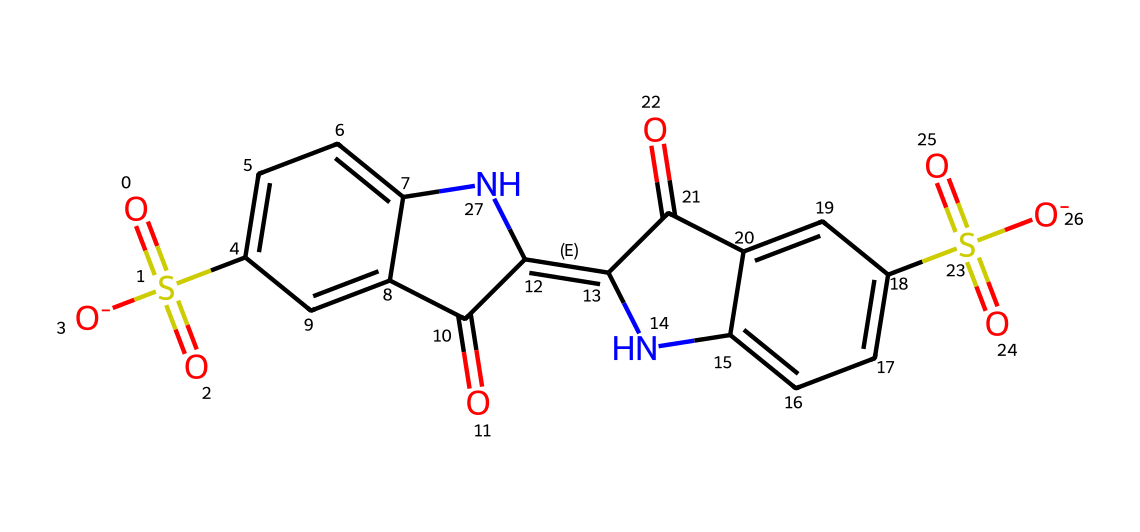How many rings are present in the molecular structure of indigo carmine? The structure shows two fused ring systems, indicating there are two rings present in the molecule.
Answer: two What is the oxidation state of the sulfur atom in indigo carmine? The sulfur atoms are associated with sulfonic acid groups, thus they are in the +6 oxidation state.
Answer: +6 How many nitrogen atoms are present in indigo carmine? Upon examining the structure, there are two nitrogen atoms incorporated in the molecular framework, visible within the rings.
Answer: two What type of functional groups are present in indigo carmine? The structure reveals the presence of sulfonic acid groups, carbonyl groups (ketone), and an imine functional group.
Answer: sulfonic acid, carbonyl, imine Which part of the indigo carmine molecule contributes to its color? The extended conjugated pi system involving the double bonds and aromatic rings influences the absorption of light, leading to its blue color.
Answer: conjugated pi system 